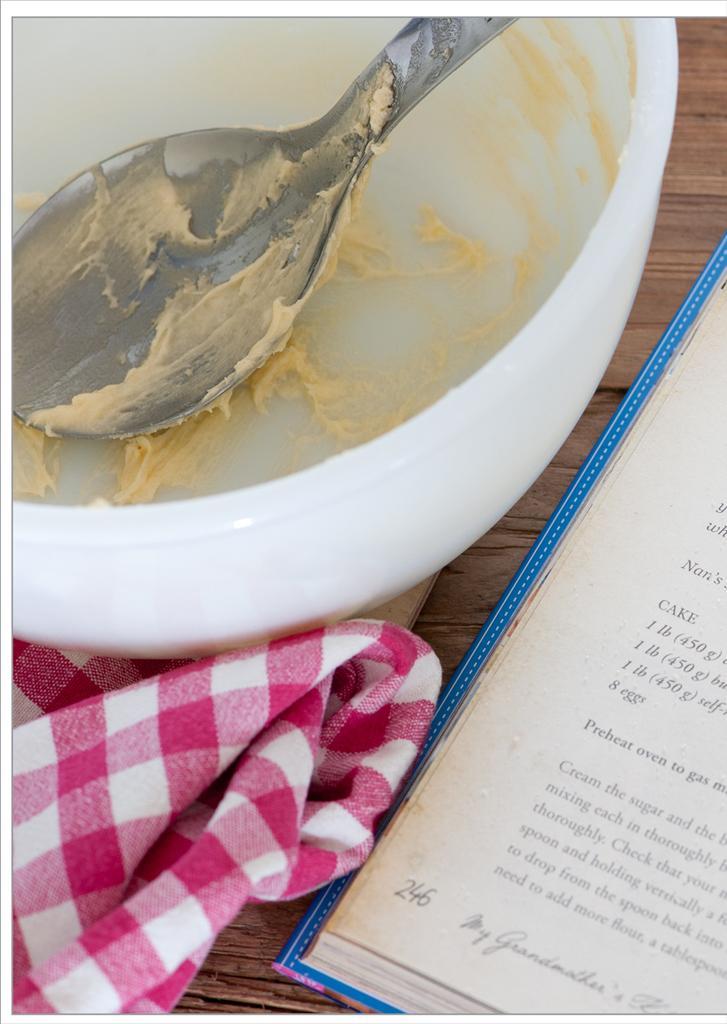How would you summarize this image in a sentence or two? In this image we can see a bowl and a spoon with some batter. We can also see the hand towel and a book on the table. 